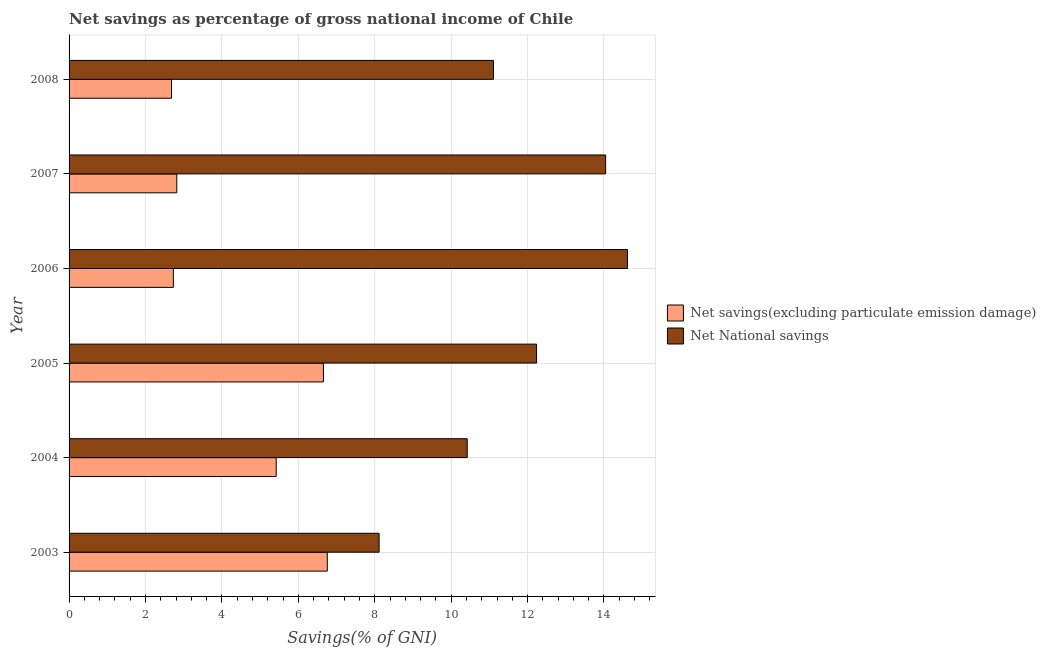How many different coloured bars are there?
Give a very brief answer. 2. How many bars are there on the 1st tick from the top?
Offer a very short reply. 2. In how many cases, is the number of bars for a given year not equal to the number of legend labels?
Offer a very short reply. 0. What is the net savings(excluding particulate emission damage) in 2005?
Offer a terse response. 6.66. Across all years, what is the maximum net savings(excluding particulate emission damage)?
Provide a short and direct response. 6.76. Across all years, what is the minimum net national savings?
Give a very brief answer. 8.11. What is the total net savings(excluding particulate emission damage) in the graph?
Your answer should be compact. 27.07. What is the difference between the net national savings in 2004 and that in 2006?
Keep it short and to the point. -4.19. What is the difference between the net savings(excluding particulate emission damage) in 2003 and the net national savings in 2004?
Offer a terse response. -3.66. What is the average net national savings per year?
Your response must be concise. 11.76. In how many years, is the net savings(excluding particulate emission damage) greater than 1.2000000000000002 %?
Provide a short and direct response. 6. What is the ratio of the net savings(excluding particulate emission damage) in 2004 to that in 2006?
Provide a short and direct response. 1.99. What is the difference between the highest and the second highest net national savings?
Ensure brevity in your answer.  0.57. Is the sum of the net national savings in 2005 and 2007 greater than the maximum net savings(excluding particulate emission damage) across all years?
Offer a terse response. Yes. What does the 2nd bar from the top in 2004 represents?
Your answer should be compact. Net savings(excluding particulate emission damage). What does the 2nd bar from the bottom in 2004 represents?
Give a very brief answer. Net National savings. What is the difference between two consecutive major ticks on the X-axis?
Keep it short and to the point. 2. Are the values on the major ticks of X-axis written in scientific E-notation?
Your response must be concise. No. Does the graph contain any zero values?
Ensure brevity in your answer.  No. Does the graph contain grids?
Provide a short and direct response. Yes. Where does the legend appear in the graph?
Give a very brief answer. Center right. How are the legend labels stacked?
Provide a short and direct response. Vertical. What is the title of the graph?
Provide a short and direct response. Net savings as percentage of gross national income of Chile. What is the label or title of the X-axis?
Make the answer very short. Savings(% of GNI). What is the Savings(% of GNI) of Net savings(excluding particulate emission damage) in 2003?
Ensure brevity in your answer.  6.76. What is the Savings(% of GNI) in Net National savings in 2003?
Give a very brief answer. 8.11. What is the Savings(% of GNI) in Net savings(excluding particulate emission damage) in 2004?
Your response must be concise. 5.42. What is the Savings(% of GNI) in Net National savings in 2004?
Provide a succinct answer. 10.42. What is the Savings(% of GNI) in Net savings(excluding particulate emission damage) in 2005?
Make the answer very short. 6.66. What is the Savings(% of GNI) of Net National savings in 2005?
Your response must be concise. 12.24. What is the Savings(% of GNI) of Net savings(excluding particulate emission damage) in 2006?
Give a very brief answer. 2.73. What is the Savings(% of GNI) of Net National savings in 2006?
Keep it short and to the point. 14.62. What is the Savings(% of GNI) in Net savings(excluding particulate emission damage) in 2007?
Offer a terse response. 2.82. What is the Savings(% of GNI) of Net National savings in 2007?
Your answer should be very brief. 14.04. What is the Savings(% of GNI) of Net savings(excluding particulate emission damage) in 2008?
Offer a terse response. 2.68. What is the Savings(% of GNI) of Net National savings in 2008?
Your answer should be compact. 11.11. Across all years, what is the maximum Savings(% of GNI) in Net savings(excluding particulate emission damage)?
Give a very brief answer. 6.76. Across all years, what is the maximum Savings(% of GNI) of Net National savings?
Your response must be concise. 14.62. Across all years, what is the minimum Savings(% of GNI) in Net savings(excluding particulate emission damage)?
Give a very brief answer. 2.68. Across all years, what is the minimum Savings(% of GNI) of Net National savings?
Offer a very short reply. 8.11. What is the total Savings(% of GNI) of Net savings(excluding particulate emission damage) in the graph?
Offer a terse response. 27.07. What is the total Savings(% of GNI) of Net National savings in the graph?
Provide a succinct answer. 70.53. What is the difference between the Savings(% of GNI) of Net savings(excluding particulate emission damage) in 2003 and that in 2004?
Your answer should be compact. 1.34. What is the difference between the Savings(% of GNI) in Net National savings in 2003 and that in 2004?
Ensure brevity in your answer.  -2.31. What is the difference between the Savings(% of GNI) of Net savings(excluding particulate emission damage) in 2003 and that in 2005?
Your answer should be very brief. 0.1. What is the difference between the Savings(% of GNI) of Net National savings in 2003 and that in 2005?
Your response must be concise. -4.12. What is the difference between the Savings(% of GNI) of Net savings(excluding particulate emission damage) in 2003 and that in 2006?
Your answer should be compact. 4.03. What is the difference between the Savings(% of GNI) in Net National savings in 2003 and that in 2006?
Ensure brevity in your answer.  -6.5. What is the difference between the Savings(% of GNI) in Net savings(excluding particulate emission damage) in 2003 and that in 2007?
Provide a short and direct response. 3.94. What is the difference between the Savings(% of GNI) in Net National savings in 2003 and that in 2007?
Provide a succinct answer. -5.93. What is the difference between the Savings(% of GNI) in Net savings(excluding particulate emission damage) in 2003 and that in 2008?
Give a very brief answer. 4.08. What is the difference between the Savings(% of GNI) in Net National savings in 2003 and that in 2008?
Give a very brief answer. -2.99. What is the difference between the Savings(% of GNI) of Net savings(excluding particulate emission damage) in 2004 and that in 2005?
Your response must be concise. -1.24. What is the difference between the Savings(% of GNI) in Net National savings in 2004 and that in 2005?
Provide a succinct answer. -1.81. What is the difference between the Savings(% of GNI) of Net savings(excluding particulate emission damage) in 2004 and that in 2006?
Provide a succinct answer. 2.69. What is the difference between the Savings(% of GNI) of Net National savings in 2004 and that in 2006?
Make the answer very short. -4.19. What is the difference between the Savings(% of GNI) of Net savings(excluding particulate emission damage) in 2004 and that in 2007?
Provide a short and direct response. 2.6. What is the difference between the Savings(% of GNI) in Net National savings in 2004 and that in 2007?
Your answer should be very brief. -3.62. What is the difference between the Savings(% of GNI) in Net savings(excluding particulate emission damage) in 2004 and that in 2008?
Keep it short and to the point. 2.74. What is the difference between the Savings(% of GNI) in Net National savings in 2004 and that in 2008?
Make the answer very short. -0.69. What is the difference between the Savings(% of GNI) in Net savings(excluding particulate emission damage) in 2005 and that in 2006?
Keep it short and to the point. 3.93. What is the difference between the Savings(% of GNI) of Net National savings in 2005 and that in 2006?
Offer a terse response. -2.38. What is the difference between the Savings(% of GNI) in Net savings(excluding particulate emission damage) in 2005 and that in 2007?
Make the answer very short. 3.84. What is the difference between the Savings(% of GNI) of Net National savings in 2005 and that in 2007?
Ensure brevity in your answer.  -1.81. What is the difference between the Savings(% of GNI) in Net savings(excluding particulate emission damage) in 2005 and that in 2008?
Ensure brevity in your answer.  3.98. What is the difference between the Savings(% of GNI) in Net National savings in 2005 and that in 2008?
Your answer should be very brief. 1.13. What is the difference between the Savings(% of GNI) of Net savings(excluding particulate emission damage) in 2006 and that in 2007?
Your answer should be very brief. -0.09. What is the difference between the Savings(% of GNI) of Net National savings in 2006 and that in 2007?
Your response must be concise. 0.57. What is the difference between the Savings(% of GNI) of Net savings(excluding particulate emission damage) in 2006 and that in 2008?
Keep it short and to the point. 0.05. What is the difference between the Savings(% of GNI) of Net National savings in 2006 and that in 2008?
Your response must be concise. 3.51. What is the difference between the Savings(% of GNI) of Net savings(excluding particulate emission damage) in 2007 and that in 2008?
Your answer should be very brief. 0.14. What is the difference between the Savings(% of GNI) in Net National savings in 2007 and that in 2008?
Keep it short and to the point. 2.94. What is the difference between the Savings(% of GNI) in Net savings(excluding particulate emission damage) in 2003 and the Savings(% of GNI) in Net National savings in 2004?
Provide a short and direct response. -3.66. What is the difference between the Savings(% of GNI) of Net savings(excluding particulate emission damage) in 2003 and the Savings(% of GNI) of Net National savings in 2005?
Ensure brevity in your answer.  -5.48. What is the difference between the Savings(% of GNI) of Net savings(excluding particulate emission damage) in 2003 and the Savings(% of GNI) of Net National savings in 2006?
Keep it short and to the point. -7.86. What is the difference between the Savings(% of GNI) of Net savings(excluding particulate emission damage) in 2003 and the Savings(% of GNI) of Net National savings in 2007?
Ensure brevity in your answer.  -7.28. What is the difference between the Savings(% of GNI) in Net savings(excluding particulate emission damage) in 2003 and the Savings(% of GNI) in Net National savings in 2008?
Make the answer very short. -4.35. What is the difference between the Savings(% of GNI) of Net savings(excluding particulate emission damage) in 2004 and the Savings(% of GNI) of Net National savings in 2005?
Keep it short and to the point. -6.81. What is the difference between the Savings(% of GNI) of Net savings(excluding particulate emission damage) in 2004 and the Savings(% of GNI) of Net National savings in 2006?
Offer a very short reply. -9.19. What is the difference between the Savings(% of GNI) of Net savings(excluding particulate emission damage) in 2004 and the Savings(% of GNI) of Net National savings in 2007?
Ensure brevity in your answer.  -8.62. What is the difference between the Savings(% of GNI) of Net savings(excluding particulate emission damage) in 2004 and the Savings(% of GNI) of Net National savings in 2008?
Your answer should be compact. -5.69. What is the difference between the Savings(% of GNI) of Net savings(excluding particulate emission damage) in 2005 and the Savings(% of GNI) of Net National savings in 2006?
Provide a succinct answer. -7.96. What is the difference between the Savings(% of GNI) of Net savings(excluding particulate emission damage) in 2005 and the Savings(% of GNI) of Net National savings in 2007?
Give a very brief answer. -7.39. What is the difference between the Savings(% of GNI) of Net savings(excluding particulate emission damage) in 2005 and the Savings(% of GNI) of Net National savings in 2008?
Your answer should be very brief. -4.45. What is the difference between the Savings(% of GNI) in Net savings(excluding particulate emission damage) in 2006 and the Savings(% of GNI) in Net National savings in 2007?
Offer a terse response. -11.31. What is the difference between the Savings(% of GNI) in Net savings(excluding particulate emission damage) in 2006 and the Savings(% of GNI) in Net National savings in 2008?
Your answer should be very brief. -8.38. What is the difference between the Savings(% of GNI) of Net savings(excluding particulate emission damage) in 2007 and the Savings(% of GNI) of Net National savings in 2008?
Offer a terse response. -8.29. What is the average Savings(% of GNI) of Net savings(excluding particulate emission damage) per year?
Give a very brief answer. 4.51. What is the average Savings(% of GNI) in Net National savings per year?
Keep it short and to the point. 11.76. In the year 2003, what is the difference between the Savings(% of GNI) of Net savings(excluding particulate emission damage) and Savings(% of GNI) of Net National savings?
Give a very brief answer. -1.36. In the year 2004, what is the difference between the Savings(% of GNI) of Net savings(excluding particulate emission damage) and Savings(% of GNI) of Net National savings?
Offer a very short reply. -5. In the year 2005, what is the difference between the Savings(% of GNI) of Net savings(excluding particulate emission damage) and Savings(% of GNI) of Net National savings?
Offer a very short reply. -5.58. In the year 2006, what is the difference between the Savings(% of GNI) in Net savings(excluding particulate emission damage) and Savings(% of GNI) in Net National savings?
Make the answer very short. -11.89. In the year 2007, what is the difference between the Savings(% of GNI) of Net savings(excluding particulate emission damage) and Savings(% of GNI) of Net National savings?
Your answer should be very brief. -11.22. In the year 2008, what is the difference between the Savings(% of GNI) in Net savings(excluding particulate emission damage) and Savings(% of GNI) in Net National savings?
Your answer should be very brief. -8.43. What is the ratio of the Savings(% of GNI) of Net savings(excluding particulate emission damage) in 2003 to that in 2004?
Your response must be concise. 1.25. What is the ratio of the Savings(% of GNI) of Net National savings in 2003 to that in 2004?
Give a very brief answer. 0.78. What is the ratio of the Savings(% of GNI) of Net savings(excluding particulate emission damage) in 2003 to that in 2005?
Your answer should be very brief. 1.02. What is the ratio of the Savings(% of GNI) of Net National savings in 2003 to that in 2005?
Provide a short and direct response. 0.66. What is the ratio of the Savings(% of GNI) of Net savings(excluding particulate emission damage) in 2003 to that in 2006?
Give a very brief answer. 2.48. What is the ratio of the Savings(% of GNI) in Net National savings in 2003 to that in 2006?
Your response must be concise. 0.56. What is the ratio of the Savings(% of GNI) of Net savings(excluding particulate emission damage) in 2003 to that in 2007?
Provide a succinct answer. 2.4. What is the ratio of the Savings(% of GNI) of Net National savings in 2003 to that in 2007?
Keep it short and to the point. 0.58. What is the ratio of the Savings(% of GNI) in Net savings(excluding particulate emission damage) in 2003 to that in 2008?
Provide a short and direct response. 2.52. What is the ratio of the Savings(% of GNI) of Net National savings in 2003 to that in 2008?
Your response must be concise. 0.73. What is the ratio of the Savings(% of GNI) in Net savings(excluding particulate emission damage) in 2004 to that in 2005?
Keep it short and to the point. 0.81. What is the ratio of the Savings(% of GNI) of Net National savings in 2004 to that in 2005?
Keep it short and to the point. 0.85. What is the ratio of the Savings(% of GNI) of Net savings(excluding particulate emission damage) in 2004 to that in 2006?
Your answer should be very brief. 1.99. What is the ratio of the Savings(% of GNI) of Net National savings in 2004 to that in 2006?
Provide a short and direct response. 0.71. What is the ratio of the Savings(% of GNI) in Net savings(excluding particulate emission damage) in 2004 to that in 2007?
Keep it short and to the point. 1.92. What is the ratio of the Savings(% of GNI) in Net National savings in 2004 to that in 2007?
Give a very brief answer. 0.74. What is the ratio of the Savings(% of GNI) of Net savings(excluding particulate emission damage) in 2004 to that in 2008?
Provide a short and direct response. 2.02. What is the ratio of the Savings(% of GNI) of Net National savings in 2004 to that in 2008?
Your answer should be very brief. 0.94. What is the ratio of the Savings(% of GNI) of Net savings(excluding particulate emission damage) in 2005 to that in 2006?
Provide a succinct answer. 2.44. What is the ratio of the Savings(% of GNI) in Net National savings in 2005 to that in 2006?
Your response must be concise. 0.84. What is the ratio of the Savings(% of GNI) of Net savings(excluding particulate emission damage) in 2005 to that in 2007?
Provide a succinct answer. 2.36. What is the ratio of the Savings(% of GNI) in Net National savings in 2005 to that in 2007?
Keep it short and to the point. 0.87. What is the ratio of the Savings(% of GNI) of Net savings(excluding particulate emission damage) in 2005 to that in 2008?
Provide a short and direct response. 2.48. What is the ratio of the Savings(% of GNI) of Net National savings in 2005 to that in 2008?
Your response must be concise. 1.1. What is the ratio of the Savings(% of GNI) of Net savings(excluding particulate emission damage) in 2006 to that in 2007?
Ensure brevity in your answer.  0.97. What is the ratio of the Savings(% of GNI) of Net National savings in 2006 to that in 2007?
Ensure brevity in your answer.  1.04. What is the ratio of the Savings(% of GNI) of Net savings(excluding particulate emission damage) in 2006 to that in 2008?
Provide a succinct answer. 1.02. What is the ratio of the Savings(% of GNI) of Net National savings in 2006 to that in 2008?
Your response must be concise. 1.32. What is the ratio of the Savings(% of GNI) of Net savings(excluding particulate emission damage) in 2007 to that in 2008?
Make the answer very short. 1.05. What is the ratio of the Savings(% of GNI) in Net National savings in 2007 to that in 2008?
Offer a very short reply. 1.26. What is the difference between the highest and the second highest Savings(% of GNI) in Net savings(excluding particulate emission damage)?
Your response must be concise. 0.1. What is the difference between the highest and the second highest Savings(% of GNI) in Net National savings?
Ensure brevity in your answer.  0.57. What is the difference between the highest and the lowest Savings(% of GNI) in Net savings(excluding particulate emission damage)?
Ensure brevity in your answer.  4.08. What is the difference between the highest and the lowest Savings(% of GNI) of Net National savings?
Offer a terse response. 6.5. 